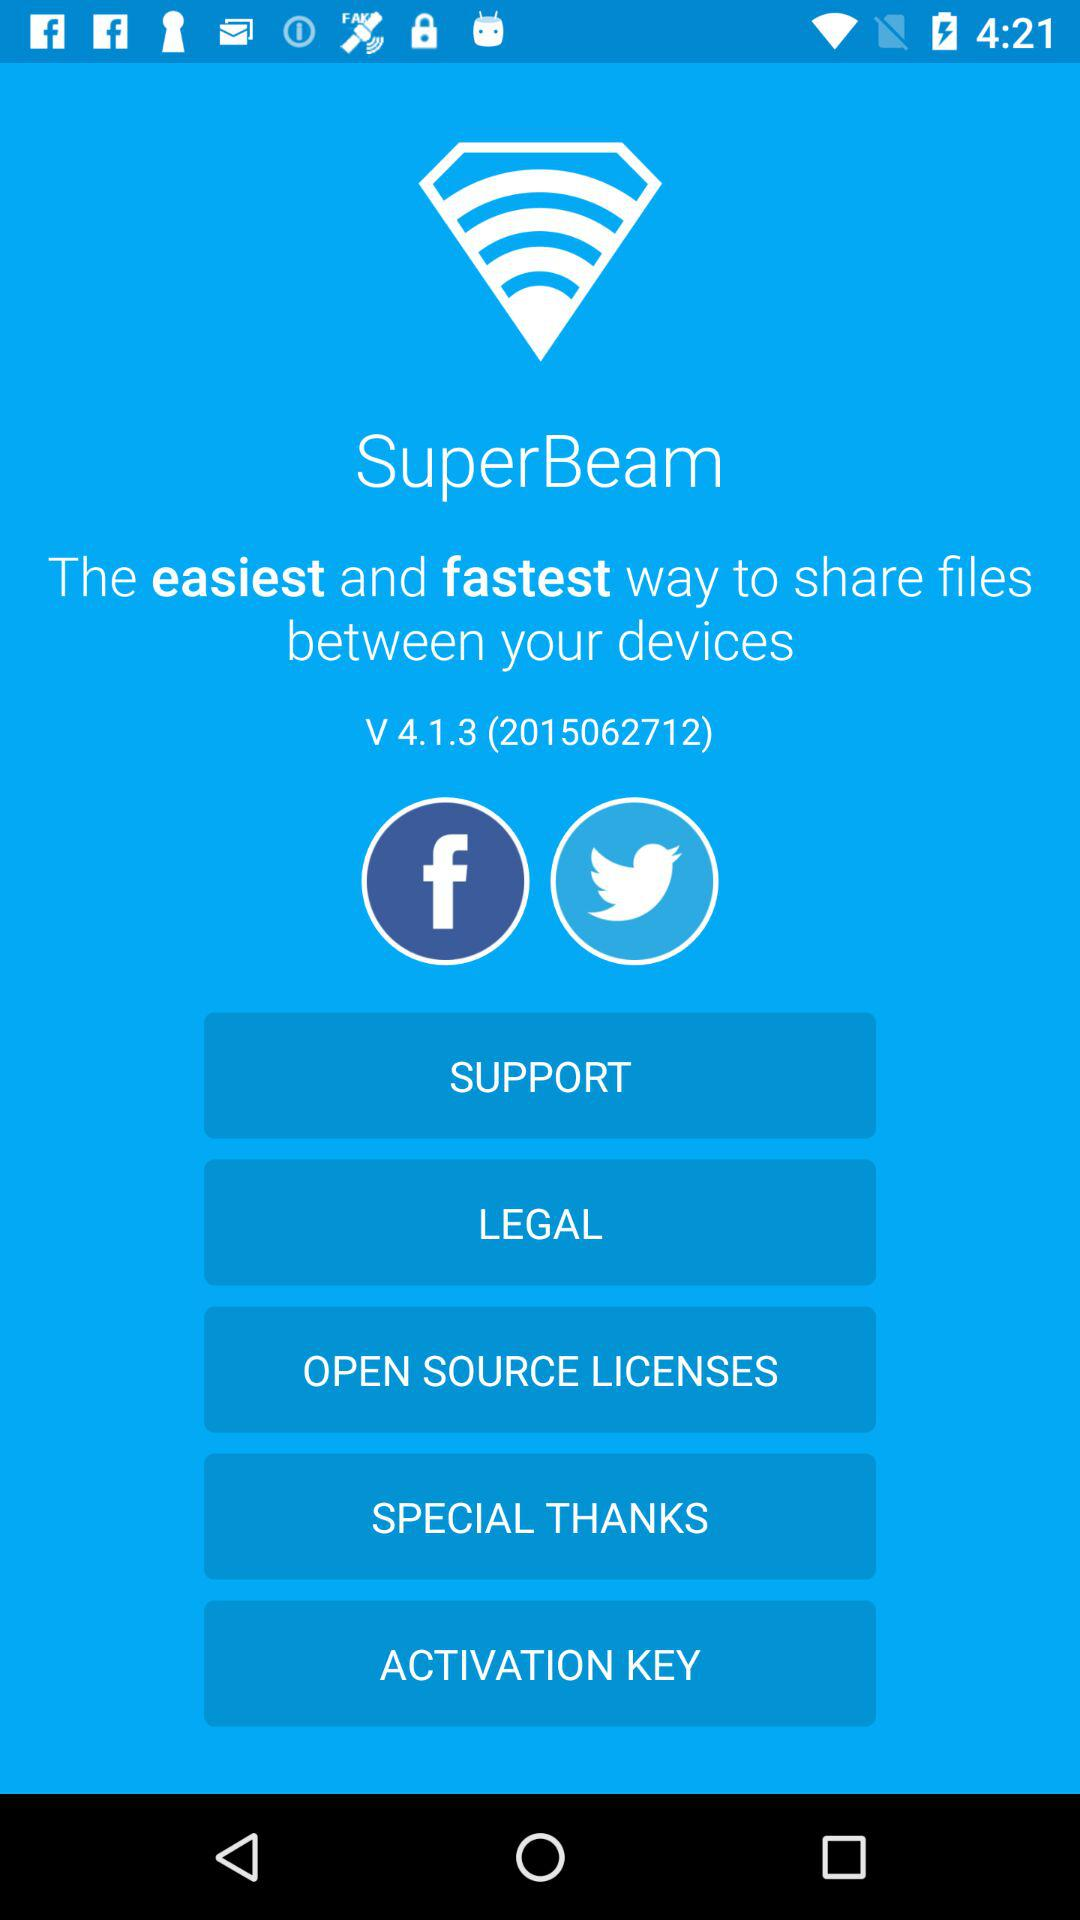What application is used? The application is "SuperBeam". 